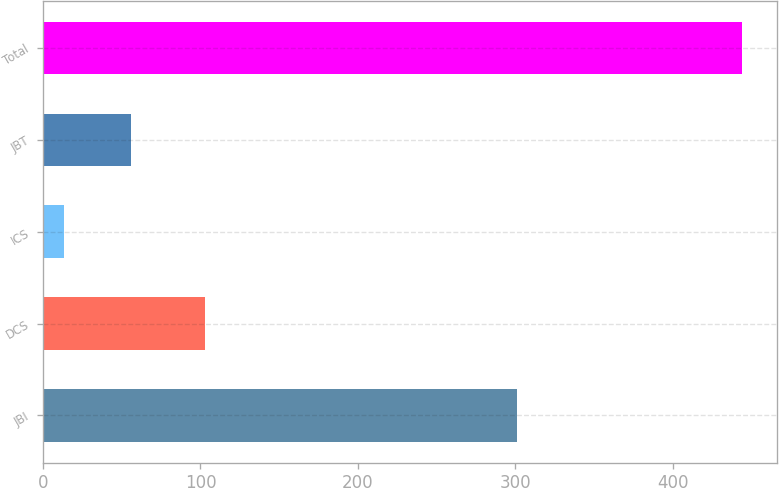Convert chart to OTSL. <chart><loc_0><loc_0><loc_500><loc_500><bar_chart><fcel>JBI<fcel>DCS<fcel>ICS<fcel>JBT<fcel>Total<nl><fcel>301<fcel>103<fcel>13<fcel>56.1<fcel>444<nl></chart> 